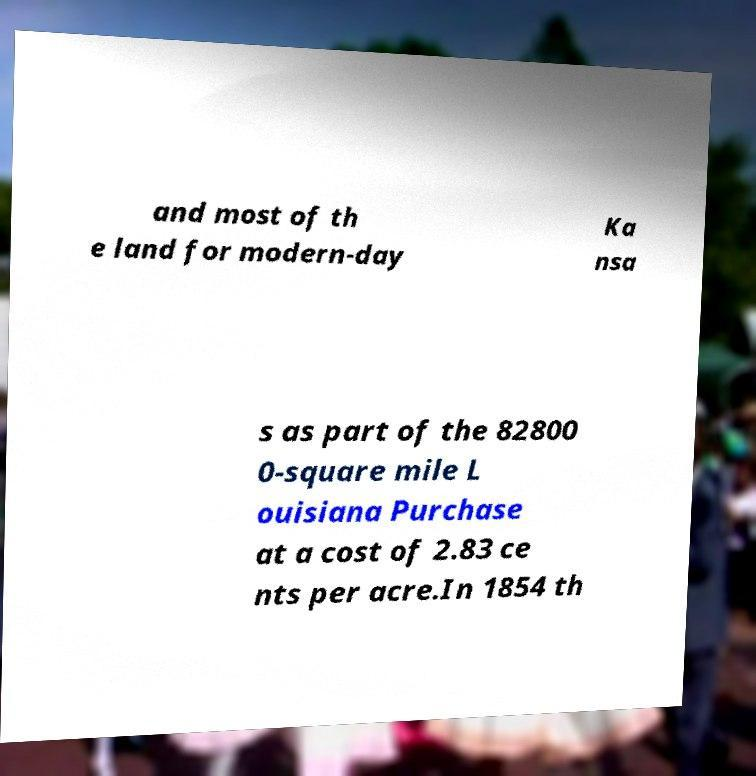Could you extract and type out the text from this image? and most of th e land for modern-day Ka nsa s as part of the 82800 0-square mile L ouisiana Purchase at a cost of 2.83 ce nts per acre.In 1854 th 